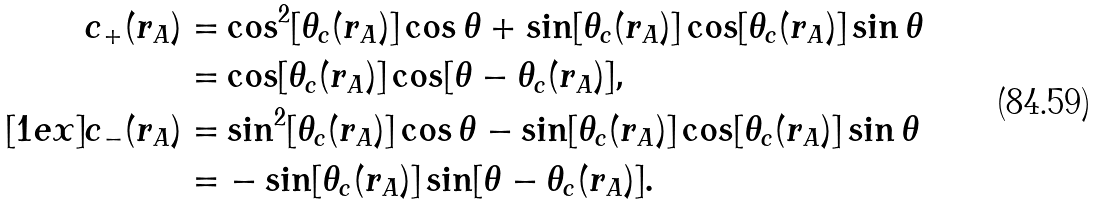Convert formula to latex. <formula><loc_0><loc_0><loc_500><loc_500>c _ { + } ( r _ { A } ) = & \cos ^ { 2 } [ \theta _ { c } ( r _ { A } ) ] \cos \theta + \sin [ \theta _ { c } ( r _ { A } ) ] \cos [ \theta _ { c } ( r _ { A } ) ] \sin \theta \\ = & \cos [ \theta _ { c } ( r _ { A } ) ] \cos [ \theta - \theta _ { c } ( r _ { A } ) ] , \\ [ 1 e x ] c _ { - } ( r _ { A } ) = & \sin ^ { 2 } [ \theta _ { c } ( r _ { A } ) ] \cos \theta - \sin [ \theta _ { c } ( r _ { A } ) ] \cos [ \theta _ { c } ( r _ { A } ) ] \sin \theta \\ = & - \sin [ \theta _ { c } ( r _ { A } ) ] \sin [ \theta - \theta _ { c } ( r _ { A } ) ] .</formula> 